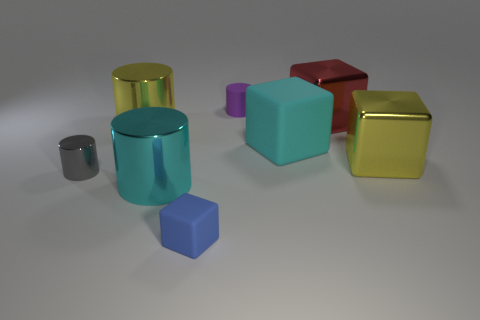Subtract all red metallic cubes. How many cubes are left? 3 Add 1 metallic things. How many objects exist? 9 Subtract all blue cubes. How many cubes are left? 3 Subtract 1 cylinders. How many cylinders are left? 3 Add 4 yellow cylinders. How many yellow cylinders exist? 5 Subtract 0 yellow spheres. How many objects are left? 8 Subtract all cyan cylinders. Subtract all red cubes. How many cylinders are left? 3 Subtract all shiny cubes. Subtract all big metallic things. How many objects are left? 2 Add 3 cyan matte cubes. How many cyan matte cubes are left? 4 